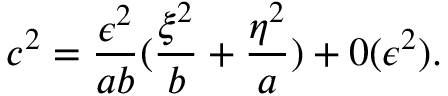Convert formula to latex. <formula><loc_0><loc_0><loc_500><loc_500>c ^ { 2 } = \frac { \epsilon ^ { 2 } } { a b } ( \frac { \xi ^ { 2 } } b + \frac { \eta ^ { 2 } } a ) + 0 ( \epsilon ^ { 2 } ) .</formula> 